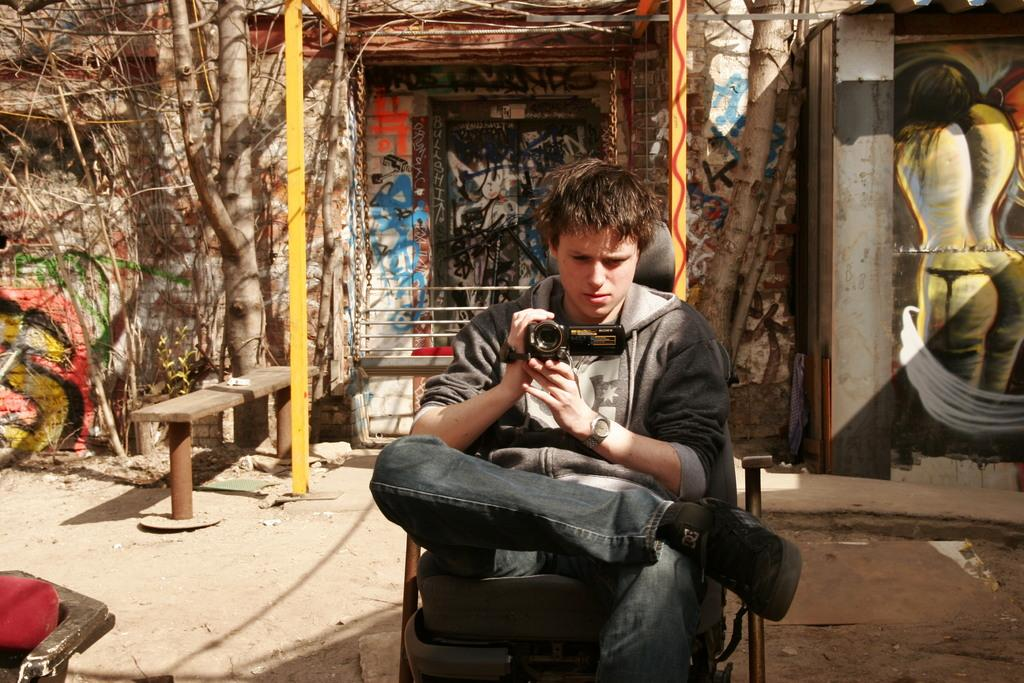What type of structure can be seen in the image? There is a wall in the image. What type of seating is present in the image? There is a bench in the image. What type of plant is visible in the image? There is a tree in the image. What is the person in the image doing? The person is sitting on a chair and holding a camera in his hand. What type of meal is being prepared on the wall in the image? There is no meal being prepared in the image, and the wall is not associated with any cooking or food preparation activities. 